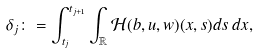Convert formula to latex. <formula><loc_0><loc_0><loc_500><loc_500>\delta _ { j } \colon = \int _ { t _ { j } } ^ { t _ { j + 1 } } \int _ { \mathbb { R } } \mathcal { H } ( b , u , w ) ( x , s ) d s \, d x ,</formula> 